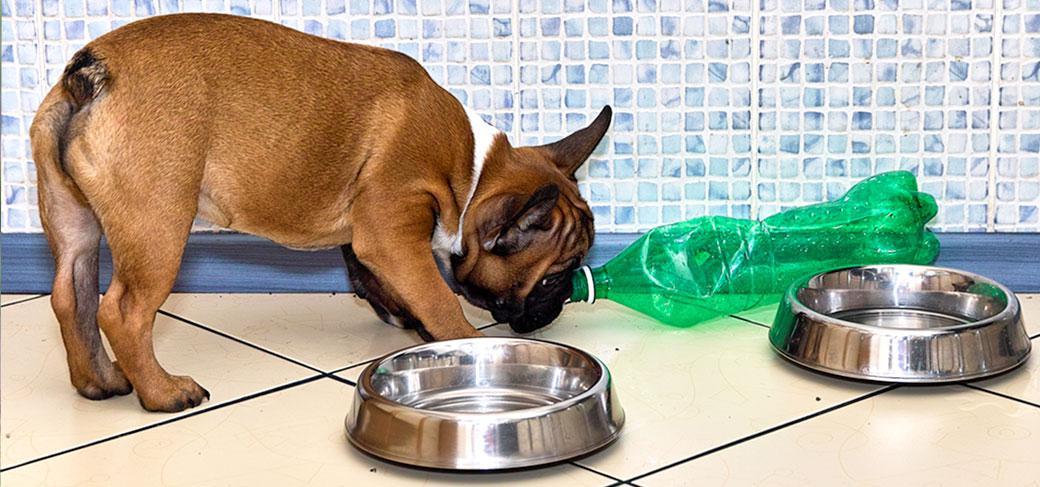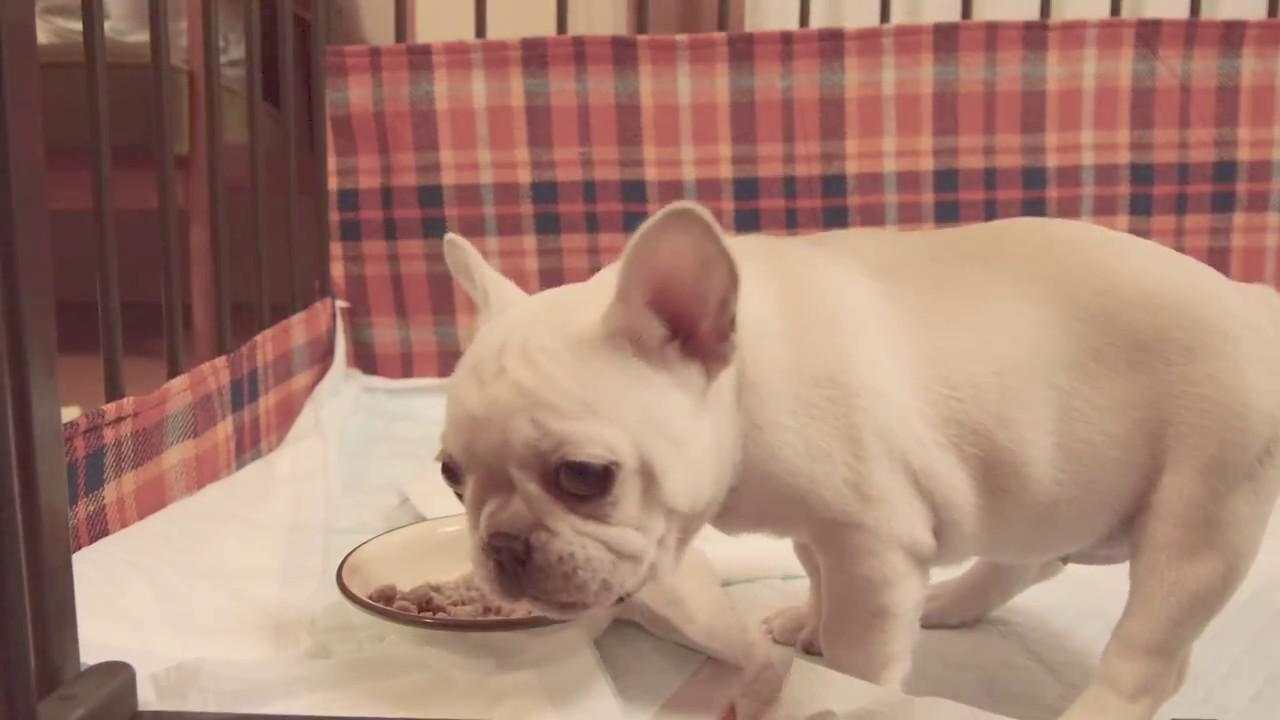The first image is the image on the left, the second image is the image on the right. For the images shown, is this caption "Each image shows a dog with a food bowl in front of it." true? Answer yes or no. Yes. The first image is the image on the left, the second image is the image on the right. For the images displayed, is the sentence "In at least one image ther is a small black puppy in a grey harness eating out of a green bowl." factually correct? Answer yes or no. No. 